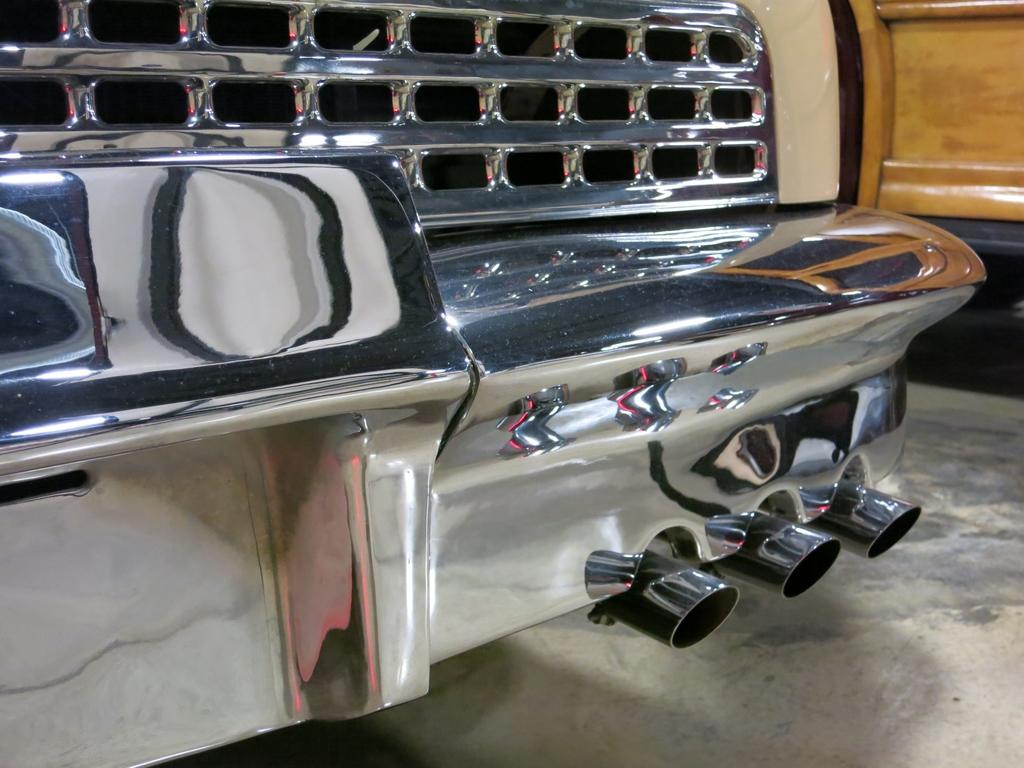What is the main subject in the center of the image? There is a car in the center of the image. What can be seen in the background of the image? There is a wall in the background of the image. What month is depicted in the image? There is no indication of a specific month in the image. What shape is the car in the image? The car in the image is not a specific shape; it is a typical car design. 